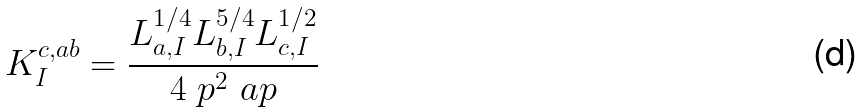Convert formula to latex. <formula><loc_0><loc_0><loc_500><loc_500>K _ { I } ^ { c , a b } = \frac { L _ { a , I } ^ { 1 / 4 } L _ { b , I } ^ { 5 / 4 } L _ { c , I } ^ { 1 / 2 } } { 4 \ p ^ { 2 } \ a p }</formula> 